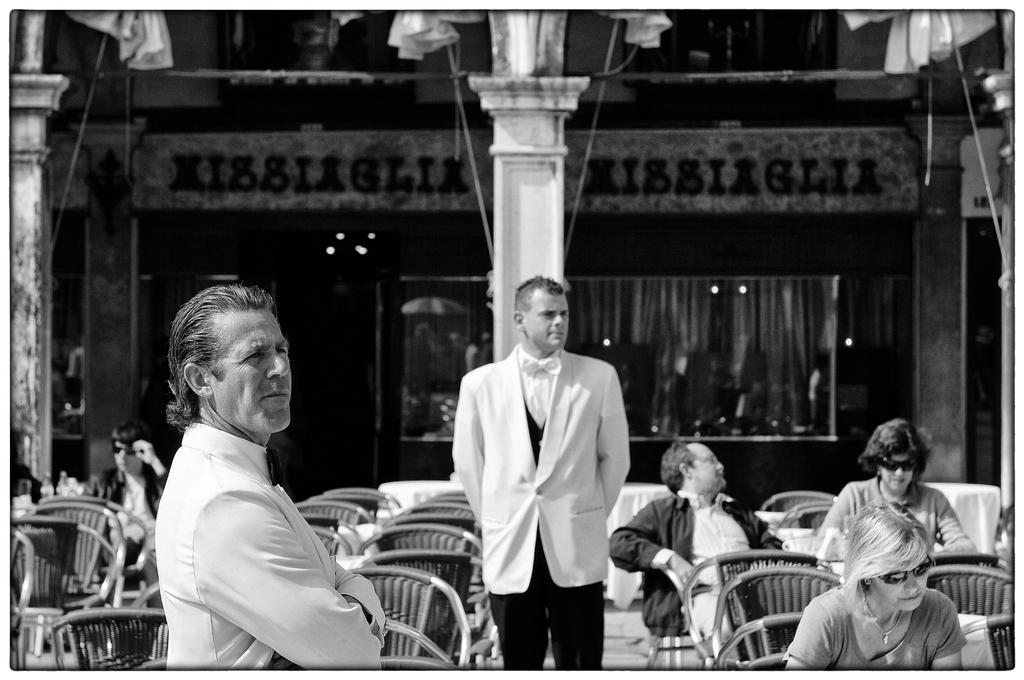What is the main subject in the middle of the image? There is a man standing in the middle of the image. What is the man wearing? The man is wearing a white coat. What are the people in the image doing? The people are sitting on chairs in the image. What type of wall can be seen in the image? There is a glass wall in the image. What can be seen in the background of the image? There is a building visible in the image. What type of development is the mother discussing with the people sitting on chairs in the image? There is no mother present in the image, nor is there any discussion about development. 